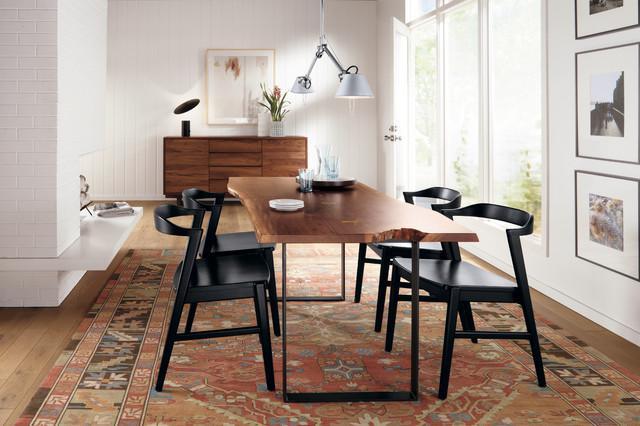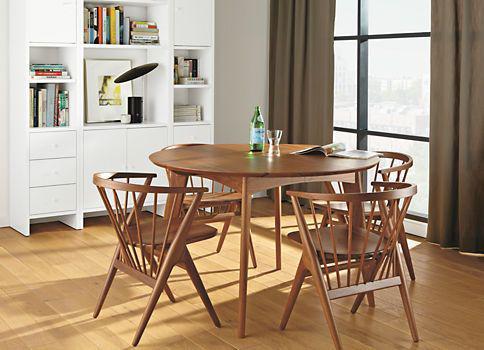The first image is the image on the left, the second image is the image on the right. Assess this claim about the two images: "In one of the images, there is a dining table and chairs placed over an area rug.". Correct or not? Answer yes or no. Yes. 